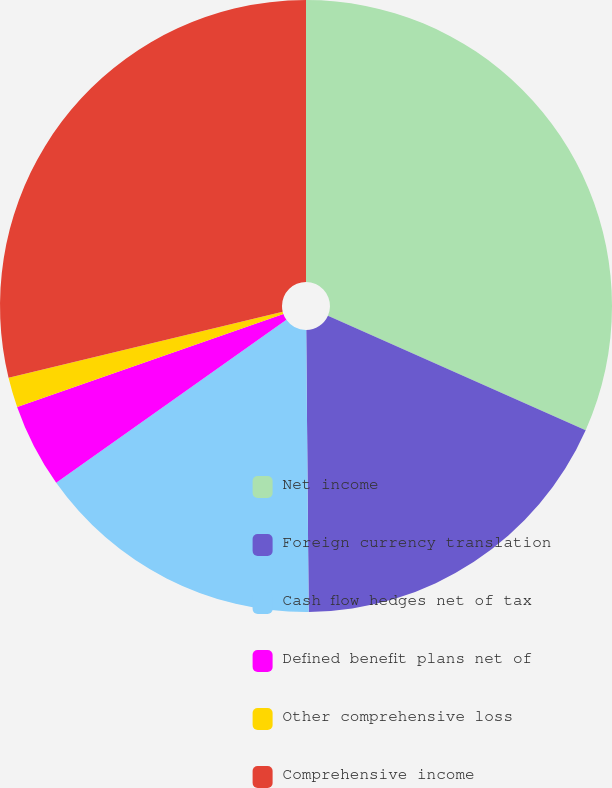<chart> <loc_0><loc_0><loc_500><loc_500><pie_chart><fcel>Net income<fcel>Foreign currency translation<fcel>Cash flow hedges net of tax<fcel>Defined benefit plans net of<fcel>Other comprehensive loss<fcel>Comprehensive income<nl><fcel>31.65%<fcel>18.21%<fcel>15.34%<fcel>4.45%<fcel>1.58%<fcel>28.77%<nl></chart> 